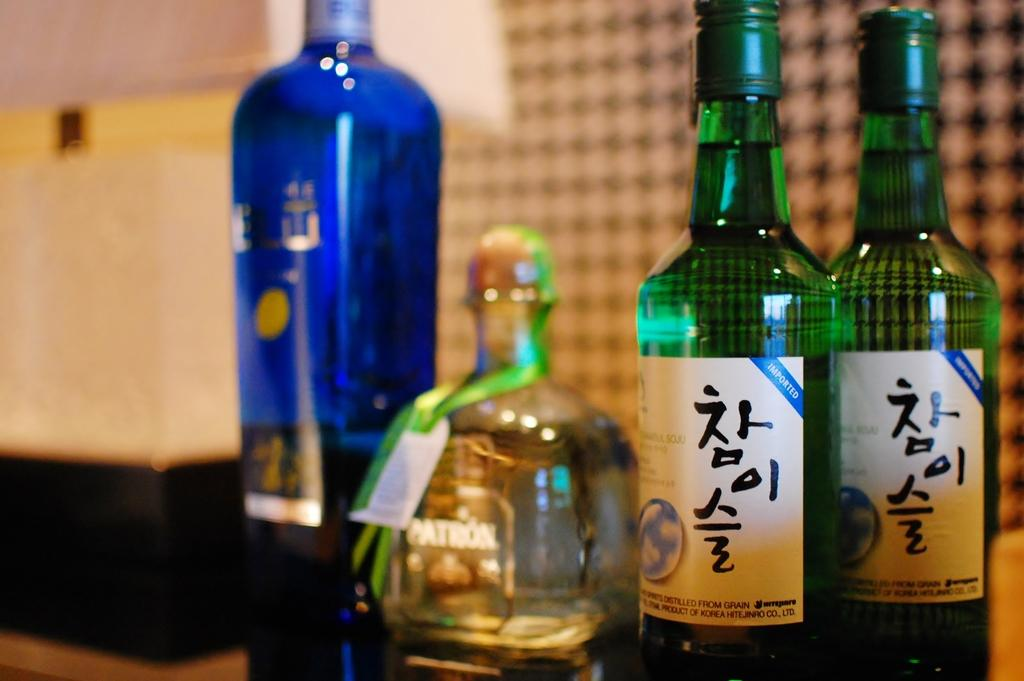How many bottles are visible in the image? There are 4 bottles in the image. What colors are the bottles? Two of the bottles are green in color, and one is blue in color. How many family members are present in the image? There are no family members present in the image; it only features bottles. What type of jar is visible in the image? There is no jar present in the image; it only features bottles. 